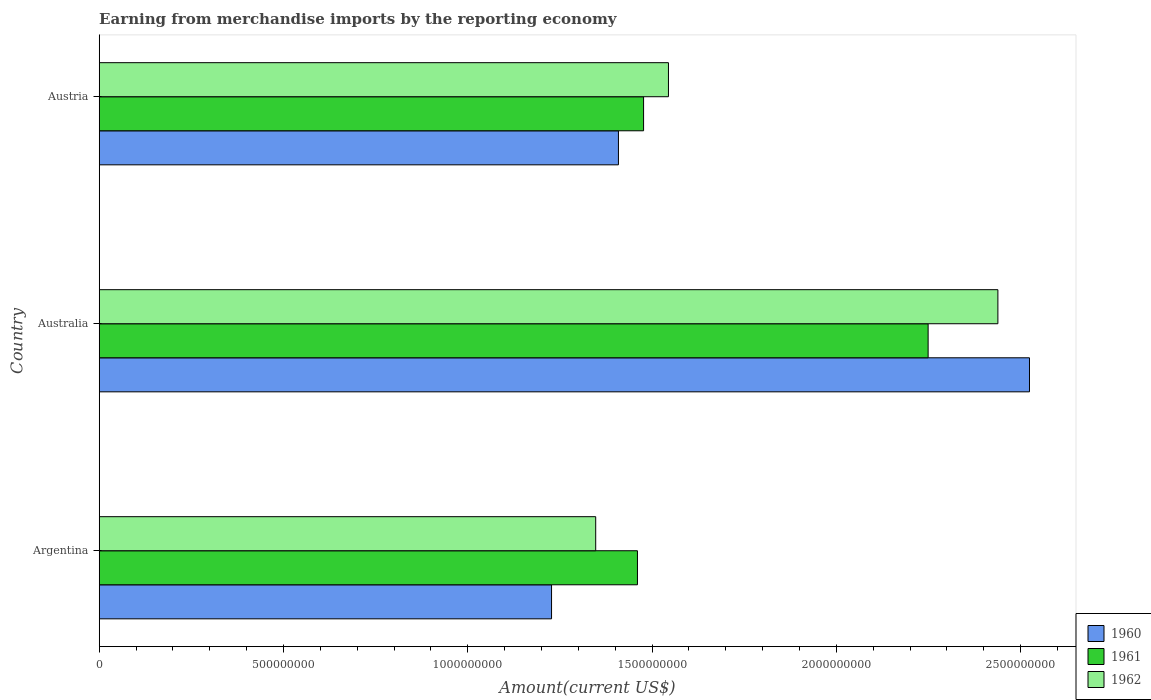How many different coloured bars are there?
Make the answer very short. 3. How many groups of bars are there?
Keep it short and to the point. 3. How many bars are there on the 3rd tick from the bottom?
Provide a short and direct response. 3. What is the label of the 2nd group of bars from the top?
Your response must be concise. Australia. In how many cases, is the number of bars for a given country not equal to the number of legend labels?
Keep it short and to the point. 0. What is the amount earned from merchandise imports in 1960 in Australia?
Offer a very short reply. 2.52e+09. Across all countries, what is the maximum amount earned from merchandise imports in 1962?
Ensure brevity in your answer.  2.44e+09. Across all countries, what is the minimum amount earned from merchandise imports in 1961?
Offer a terse response. 1.46e+09. What is the total amount earned from merchandise imports in 1961 in the graph?
Make the answer very short. 5.19e+09. What is the difference between the amount earned from merchandise imports in 1960 in Argentina and that in Austria?
Give a very brief answer. -1.82e+08. What is the difference between the amount earned from merchandise imports in 1962 in Australia and the amount earned from merchandise imports in 1961 in Austria?
Offer a very short reply. 9.61e+08. What is the average amount earned from merchandise imports in 1961 per country?
Provide a succinct answer. 1.73e+09. What is the difference between the amount earned from merchandise imports in 1961 and amount earned from merchandise imports in 1960 in Argentina?
Keep it short and to the point. 2.33e+08. In how many countries, is the amount earned from merchandise imports in 1960 greater than 100000000 US$?
Ensure brevity in your answer.  3. What is the ratio of the amount earned from merchandise imports in 1961 in Australia to that in Austria?
Your response must be concise. 1.52. Is the amount earned from merchandise imports in 1960 in Argentina less than that in Australia?
Offer a terse response. Yes. Is the difference between the amount earned from merchandise imports in 1961 in Argentina and Austria greater than the difference between the amount earned from merchandise imports in 1960 in Argentina and Austria?
Ensure brevity in your answer.  Yes. What is the difference between the highest and the second highest amount earned from merchandise imports in 1960?
Give a very brief answer. 1.12e+09. What is the difference between the highest and the lowest amount earned from merchandise imports in 1962?
Ensure brevity in your answer.  1.09e+09. Is the sum of the amount earned from merchandise imports in 1960 in Australia and Austria greater than the maximum amount earned from merchandise imports in 1962 across all countries?
Your response must be concise. Yes. Is it the case that in every country, the sum of the amount earned from merchandise imports in 1962 and amount earned from merchandise imports in 1960 is greater than the amount earned from merchandise imports in 1961?
Give a very brief answer. Yes. How many bars are there?
Make the answer very short. 9. How many countries are there in the graph?
Provide a short and direct response. 3. Are the values on the major ticks of X-axis written in scientific E-notation?
Make the answer very short. No. Does the graph contain any zero values?
Provide a short and direct response. No. Does the graph contain grids?
Ensure brevity in your answer.  No. How many legend labels are there?
Provide a short and direct response. 3. How are the legend labels stacked?
Keep it short and to the point. Vertical. What is the title of the graph?
Keep it short and to the point. Earning from merchandise imports by the reporting economy. Does "1989" appear as one of the legend labels in the graph?
Your response must be concise. No. What is the label or title of the X-axis?
Give a very brief answer. Amount(current US$). What is the label or title of the Y-axis?
Provide a short and direct response. Country. What is the Amount(current US$) in 1960 in Argentina?
Your answer should be compact. 1.23e+09. What is the Amount(current US$) of 1961 in Argentina?
Ensure brevity in your answer.  1.46e+09. What is the Amount(current US$) of 1962 in Argentina?
Provide a short and direct response. 1.35e+09. What is the Amount(current US$) in 1960 in Australia?
Ensure brevity in your answer.  2.52e+09. What is the Amount(current US$) of 1961 in Australia?
Offer a very short reply. 2.25e+09. What is the Amount(current US$) of 1962 in Australia?
Your answer should be compact. 2.44e+09. What is the Amount(current US$) in 1960 in Austria?
Offer a terse response. 1.41e+09. What is the Amount(current US$) in 1961 in Austria?
Ensure brevity in your answer.  1.48e+09. What is the Amount(current US$) of 1962 in Austria?
Keep it short and to the point. 1.54e+09. Across all countries, what is the maximum Amount(current US$) in 1960?
Offer a terse response. 2.52e+09. Across all countries, what is the maximum Amount(current US$) of 1961?
Your answer should be very brief. 2.25e+09. Across all countries, what is the maximum Amount(current US$) in 1962?
Make the answer very short. 2.44e+09. Across all countries, what is the minimum Amount(current US$) in 1960?
Your response must be concise. 1.23e+09. Across all countries, what is the minimum Amount(current US$) of 1961?
Ensure brevity in your answer.  1.46e+09. Across all countries, what is the minimum Amount(current US$) in 1962?
Offer a very short reply. 1.35e+09. What is the total Amount(current US$) in 1960 in the graph?
Ensure brevity in your answer.  5.16e+09. What is the total Amount(current US$) in 1961 in the graph?
Your answer should be compact. 5.19e+09. What is the total Amount(current US$) in 1962 in the graph?
Offer a terse response. 5.33e+09. What is the difference between the Amount(current US$) in 1960 in Argentina and that in Australia?
Your response must be concise. -1.30e+09. What is the difference between the Amount(current US$) of 1961 in Argentina and that in Australia?
Make the answer very short. -7.89e+08. What is the difference between the Amount(current US$) of 1962 in Argentina and that in Australia?
Ensure brevity in your answer.  -1.09e+09. What is the difference between the Amount(current US$) of 1960 in Argentina and that in Austria?
Your answer should be very brief. -1.82e+08. What is the difference between the Amount(current US$) of 1961 in Argentina and that in Austria?
Provide a short and direct response. -1.66e+07. What is the difference between the Amount(current US$) in 1962 in Argentina and that in Austria?
Keep it short and to the point. -1.97e+08. What is the difference between the Amount(current US$) in 1960 in Australia and that in Austria?
Offer a terse response. 1.12e+09. What is the difference between the Amount(current US$) in 1961 in Australia and that in Austria?
Give a very brief answer. 7.72e+08. What is the difference between the Amount(current US$) in 1962 in Australia and that in Austria?
Provide a succinct answer. 8.94e+08. What is the difference between the Amount(current US$) in 1960 in Argentina and the Amount(current US$) in 1961 in Australia?
Make the answer very short. -1.02e+09. What is the difference between the Amount(current US$) of 1960 in Argentina and the Amount(current US$) of 1962 in Australia?
Ensure brevity in your answer.  -1.21e+09. What is the difference between the Amount(current US$) in 1961 in Argentina and the Amount(current US$) in 1962 in Australia?
Ensure brevity in your answer.  -9.78e+08. What is the difference between the Amount(current US$) of 1960 in Argentina and the Amount(current US$) of 1961 in Austria?
Your answer should be compact. -2.50e+08. What is the difference between the Amount(current US$) in 1960 in Argentina and the Amount(current US$) in 1962 in Austria?
Your answer should be compact. -3.17e+08. What is the difference between the Amount(current US$) of 1961 in Argentina and the Amount(current US$) of 1962 in Austria?
Your answer should be compact. -8.41e+07. What is the difference between the Amount(current US$) of 1960 in Australia and the Amount(current US$) of 1961 in Austria?
Keep it short and to the point. 1.05e+09. What is the difference between the Amount(current US$) of 1960 in Australia and the Amount(current US$) of 1962 in Austria?
Offer a terse response. 9.80e+08. What is the difference between the Amount(current US$) in 1961 in Australia and the Amount(current US$) in 1962 in Austria?
Provide a succinct answer. 7.05e+08. What is the average Amount(current US$) of 1960 per country?
Provide a succinct answer. 1.72e+09. What is the average Amount(current US$) in 1961 per country?
Offer a terse response. 1.73e+09. What is the average Amount(current US$) in 1962 per country?
Provide a succinct answer. 1.78e+09. What is the difference between the Amount(current US$) of 1960 and Amount(current US$) of 1961 in Argentina?
Provide a succinct answer. -2.33e+08. What is the difference between the Amount(current US$) in 1960 and Amount(current US$) in 1962 in Argentina?
Provide a succinct answer. -1.20e+08. What is the difference between the Amount(current US$) in 1961 and Amount(current US$) in 1962 in Argentina?
Keep it short and to the point. 1.13e+08. What is the difference between the Amount(current US$) of 1960 and Amount(current US$) of 1961 in Australia?
Your answer should be very brief. 2.75e+08. What is the difference between the Amount(current US$) of 1960 and Amount(current US$) of 1962 in Australia?
Keep it short and to the point. 8.57e+07. What is the difference between the Amount(current US$) of 1961 and Amount(current US$) of 1962 in Australia?
Make the answer very short. -1.89e+08. What is the difference between the Amount(current US$) in 1960 and Amount(current US$) in 1961 in Austria?
Your response must be concise. -6.82e+07. What is the difference between the Amount(current US$) in 1960 and Amount(current US$) in 1962 in Austria?
Provide a succinct answer. -1.36e+08. What is the difference between the Amount(current US$) of 1961 and Amount(current US$) of 1962 in Austria?
Make the answer very short. -6.75e+07. What is the ratio of the Amount(current US$) in 1960 in Argentina to that in Australia?
Give a very brief answer. 0.49. What is the ratio of the Amount(current US$) in 1961 in Argentina to that in Australia?
Ensure brevity in your answer.  0.65. What is the ratio of the Amount(current US$) of 1962 in Argentina to that in Australia?
Your answer should be compact. 0.55. What is the ratio of the Amount(current US$) in 1960 in Argentina to that in Austria?
Give a very brief answer. 0.87. What is the ratio of the Amount(current US$) of 1962 in Argentina to that in Austria?
Your response must be concise. 0.87. What is the ratio of the Amount(current US$) of 1960 in Australia to that in Austria?
Your response must be concise. 1.79. What is the ratio of the Amount(current US$) of 1961 in Australia to that in Austria?
Keep it short and to the point. 1.52. What is the ratio of the Amount(current US$) in 1962 in Australia to that in Austria?
Offer a terse response. 1.58. What is the difference between the highest and the second highest Amount(current US$) in 1960?
Keep it short and to the point. 1.12e+09. What is the difference between the highest and the second highest Amount(current US$) of 1961?
Your answer should be compact. 7.72e+08. What is the difference between the highest and the second highest Amount(current US$) in 1962?
Ensure brevity in your answer.  8.94e+08. What is the difference between the highest and the lowest Amount(current US$) of 1960?
Provide a short and direct response. 1.30e+09. What is the difference between the highest and the lowest Amount(current US$) in 1961?
Offer a terse response. 7.89e+08. What is the difference between the highest and the lowest Amount(current US$) of 1962?
Keep it short and to the point. 1.09e+09. 